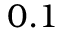<formula> <loc_0><loc_0><loc_500><loc_500>0 . 1</formula> 